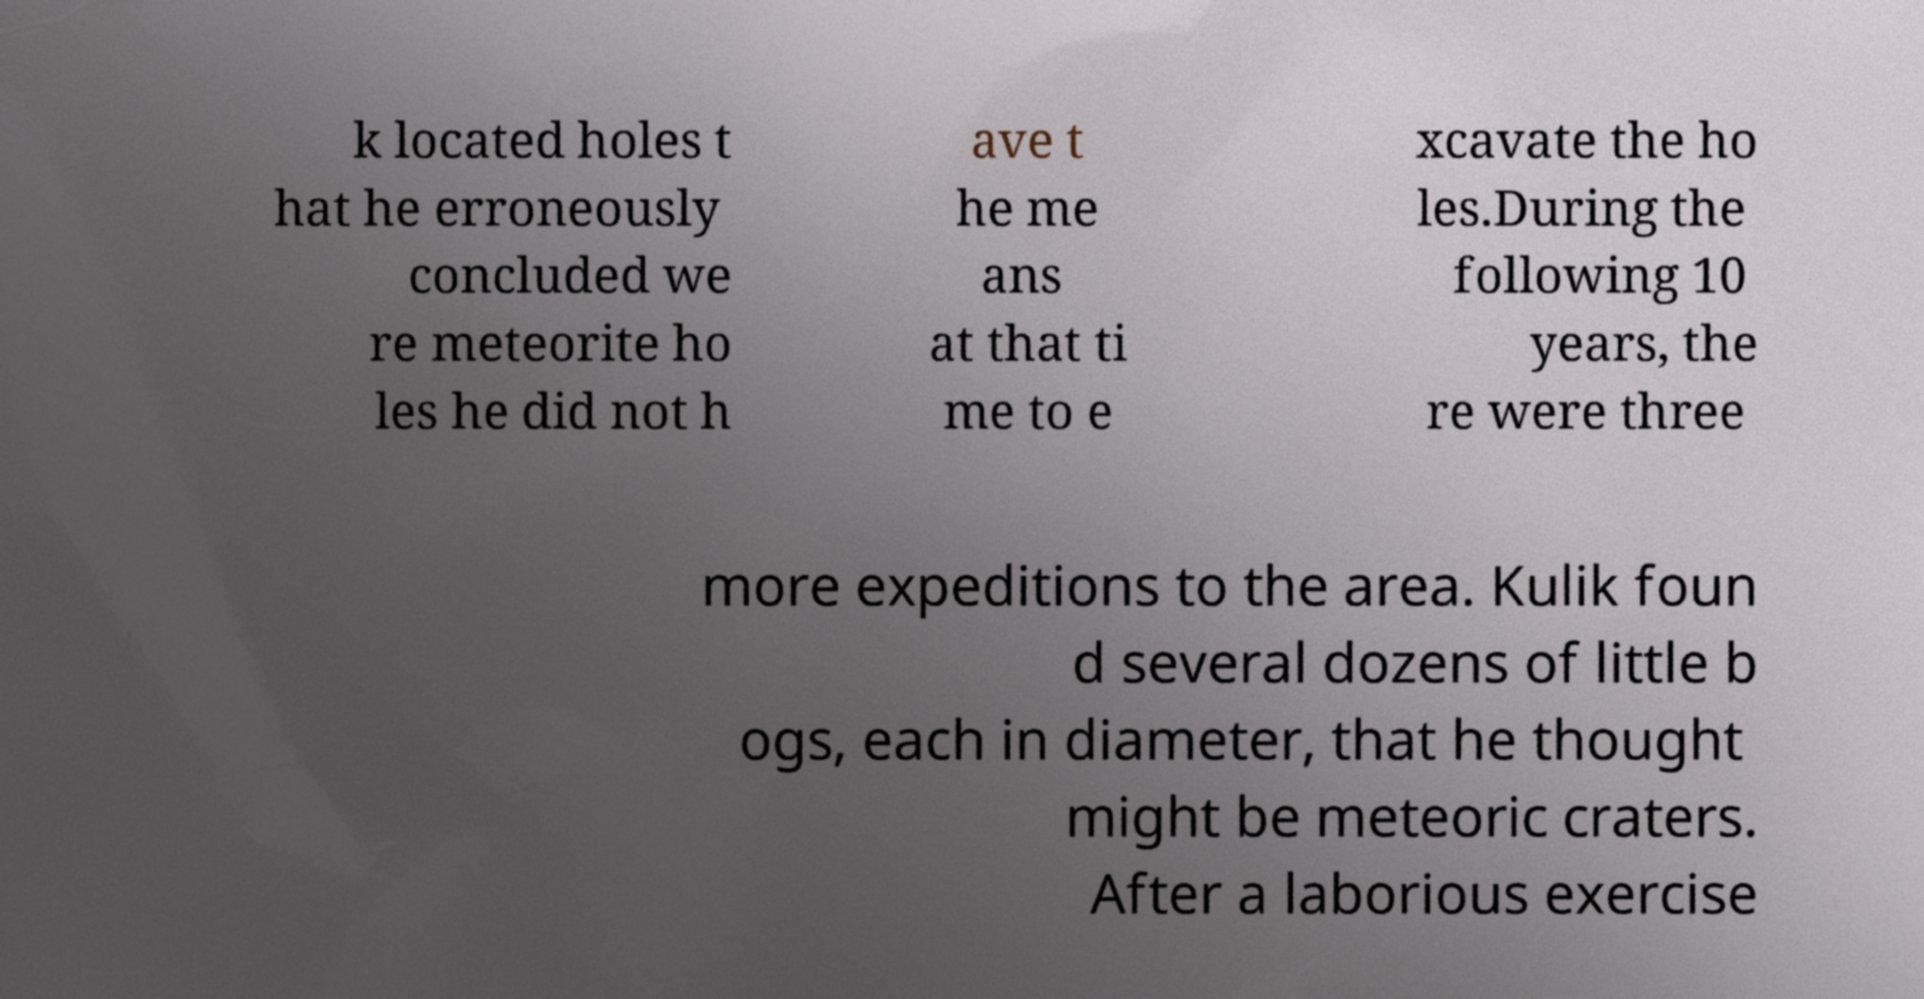What messages or text are displayed in this image? I need them in a readable, typed format. k located holes t hat he erroneously concluded we re meteorite ho les he did not h ave t he me ans at that ti me to e xcavate the ho les.During the following 10 years, the re were three more expeditions to the area. Kulik foun d several dozens of little b ogs, each in diameter, that he thought might be meteoric craters. After a laborious exercise 